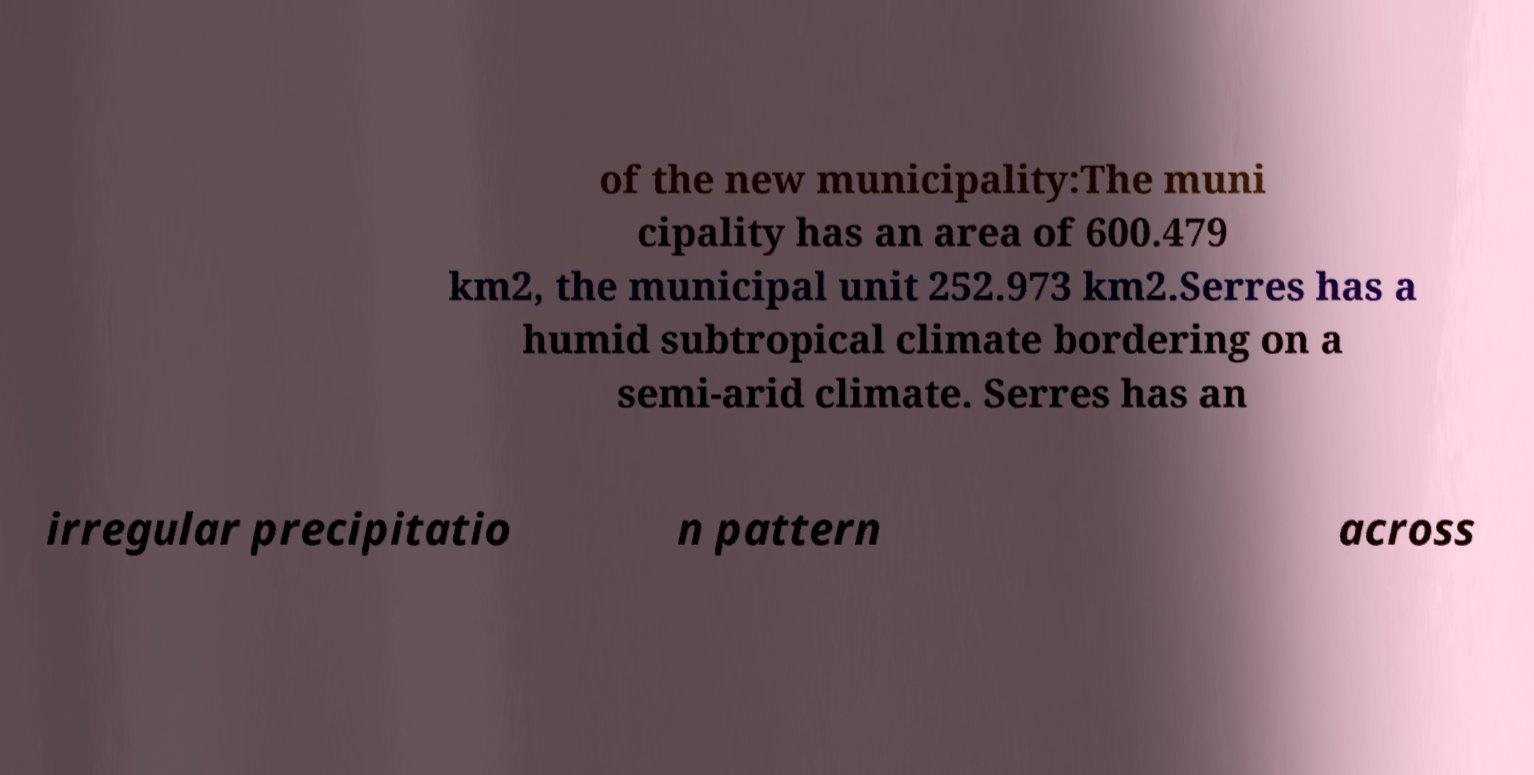Please read and relay the text visible in this image. What does it say? of the new municipality:The muni cipality has an area of 600.479 km2, the municipal unit 252.973 km2.Serres has a humid subtropical climate bordering on a semi-arid climate. Serres has an irregular precipitatio n pattern across 